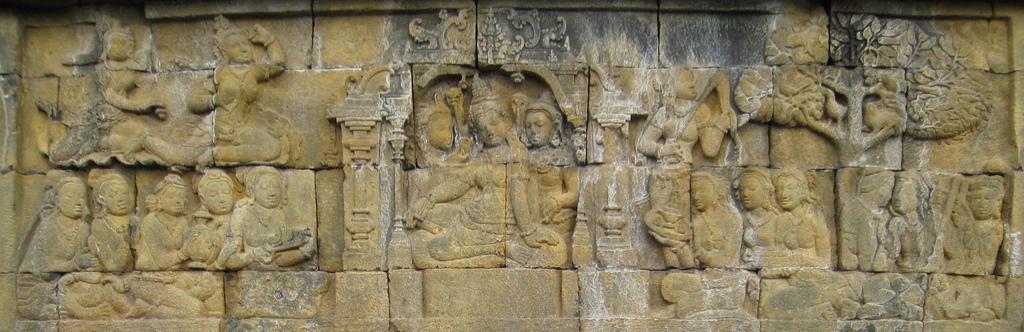Please provide a concise description of this image. We can see sculptures on the wall. 